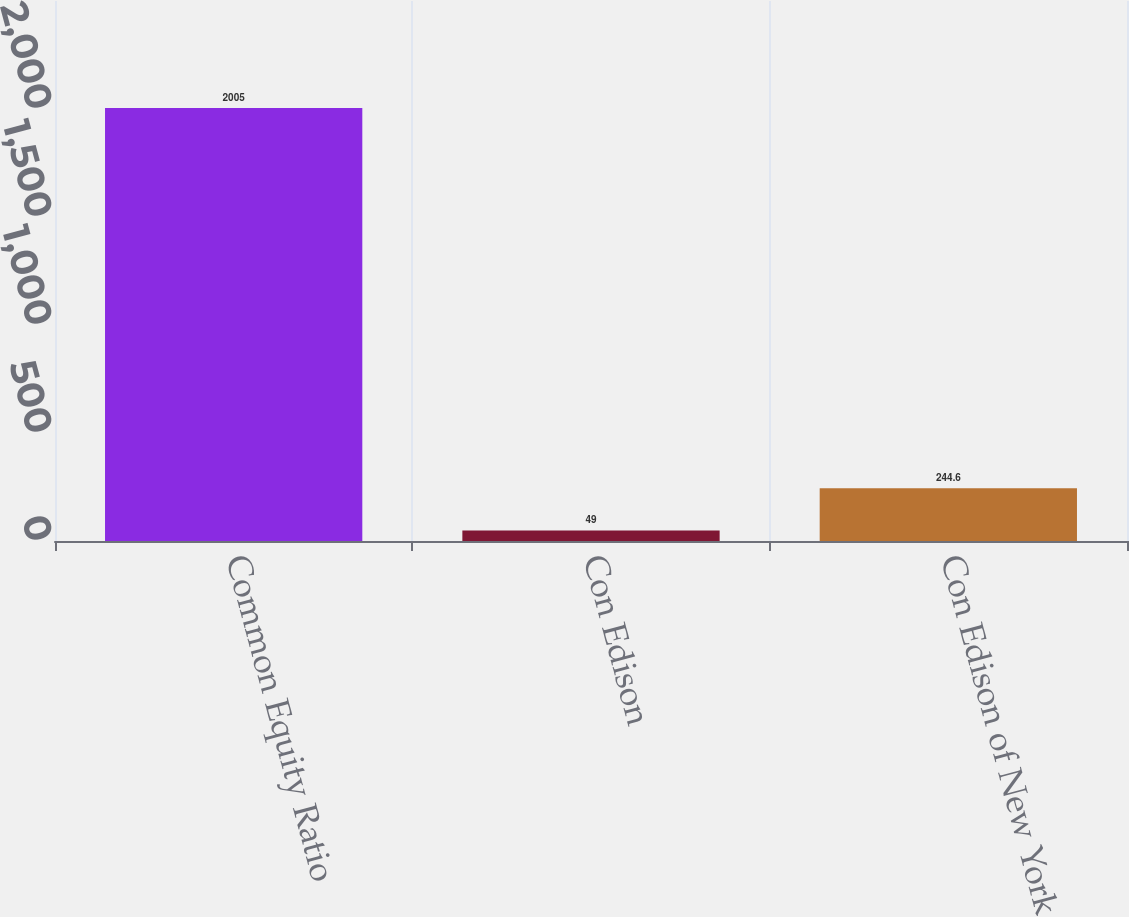Convert chart to OTSL. <chart><loc_0><loc_0><loc_500><loc_500><bar_chart><fcel>Common Equity Ratio<fcel>Con Edison<fcel>Con Edison of New York<nl><fcel>2005<fcel>49<fcel>244.6<nl></chart> 